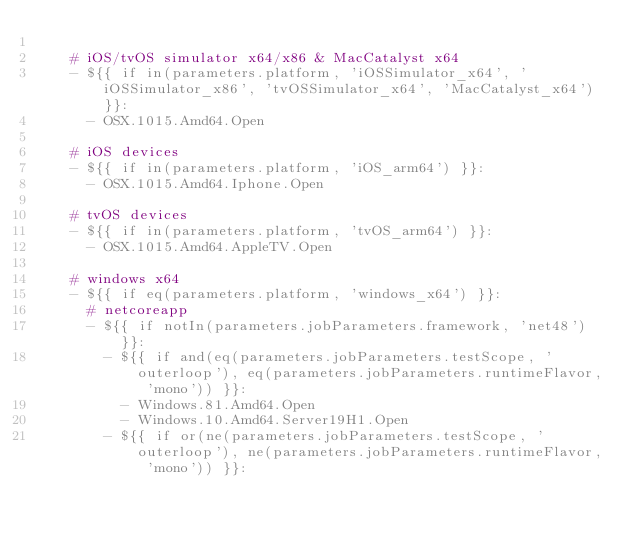Convert code to text. <code><loc_0><loc_0><loc_500><loc_500><_YAML_>
    # iOS/tvOS simulator x64/x86 & MacCatalyst x64
    - ${{ if in(parameters.platform, 'iOSSimulator_x64', 'iOSSimulator_x86', 'tvOSSimulator_x64', 'MacCatalyst_x64') }}:
      - OSX.1015.Amd64.Open

    # iOS devices
    - ${{ if in(parameters.platform, 'iOS_arm64') }}:
      - OSX.1015.Amd64.Iphone.Open

    # tvOS devices
    - ${{ if in(parameters.platform, 'tvOS_arm64') }}:
      - OSX.1015.Amd64.AppleTV.Open

    # windows x64
    - ${{ if eq(parameters.platform, 'windows_x64') }}:
      # netcoreapp
      - ${{ if notIn(parameters.jobParameters.framework, 'net48') }}:
        - ${{ if and(eq(parameters.jobParameters.testScope, 'outerloop'), eq(parameters.jobParameters.runtimeFlavor, 'mono')) }}:
          - Windows.81.Amd64.Open
          - Windows.10.Amd64.Server19H1.Open
        - ${{ if or(ne(parameters.jobParameters.testScope, 'outerloop'), ne(parameters.jobParameters.runtimeFlavor, 'mono')) }}:</code> 